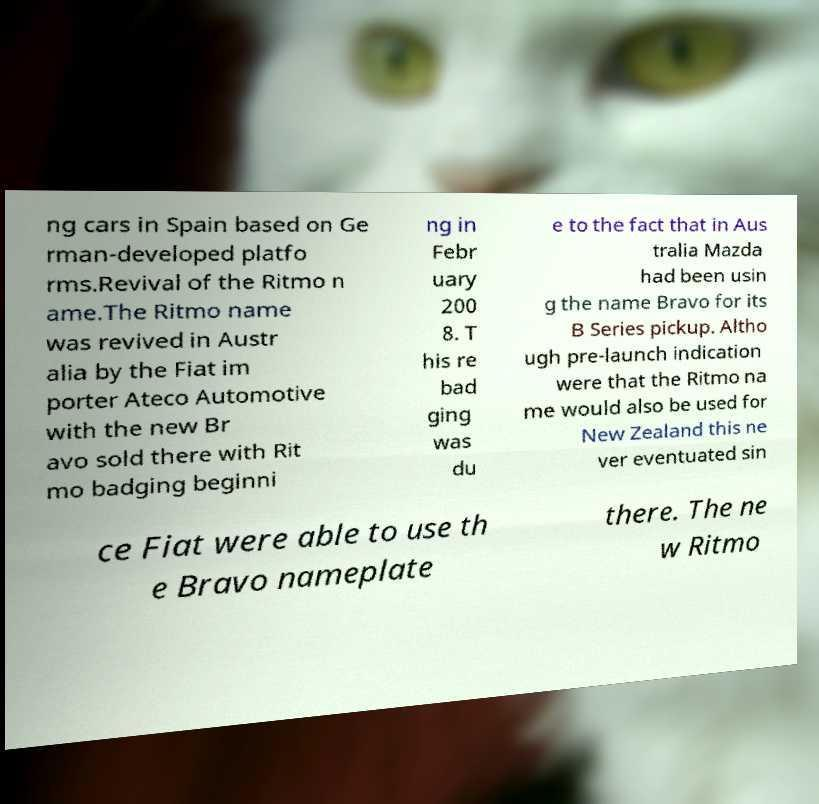Could you extract and type out the text from this image? ng cars in Spain based on Ge rman-developed platfo rms.Revival of the Ritmo n ame.The Ritmo name was revived in Austr alia by the Fiat im porter Ateco Automotive with the new Br avo sold there with Rit mo badging beginni ng in Febr uary 200 8. T his re bad ging was du e to the fact that in Aus tralia Mazda had been usin g the name Bravo for its B Series pickup. Altho ugh pre-launch indication were that the Ritmo na me would also be used for New Zealand this ne ver eventuated sin ce Fiat were able to use th e Bravo nameplate there. The ne w Ritmo 